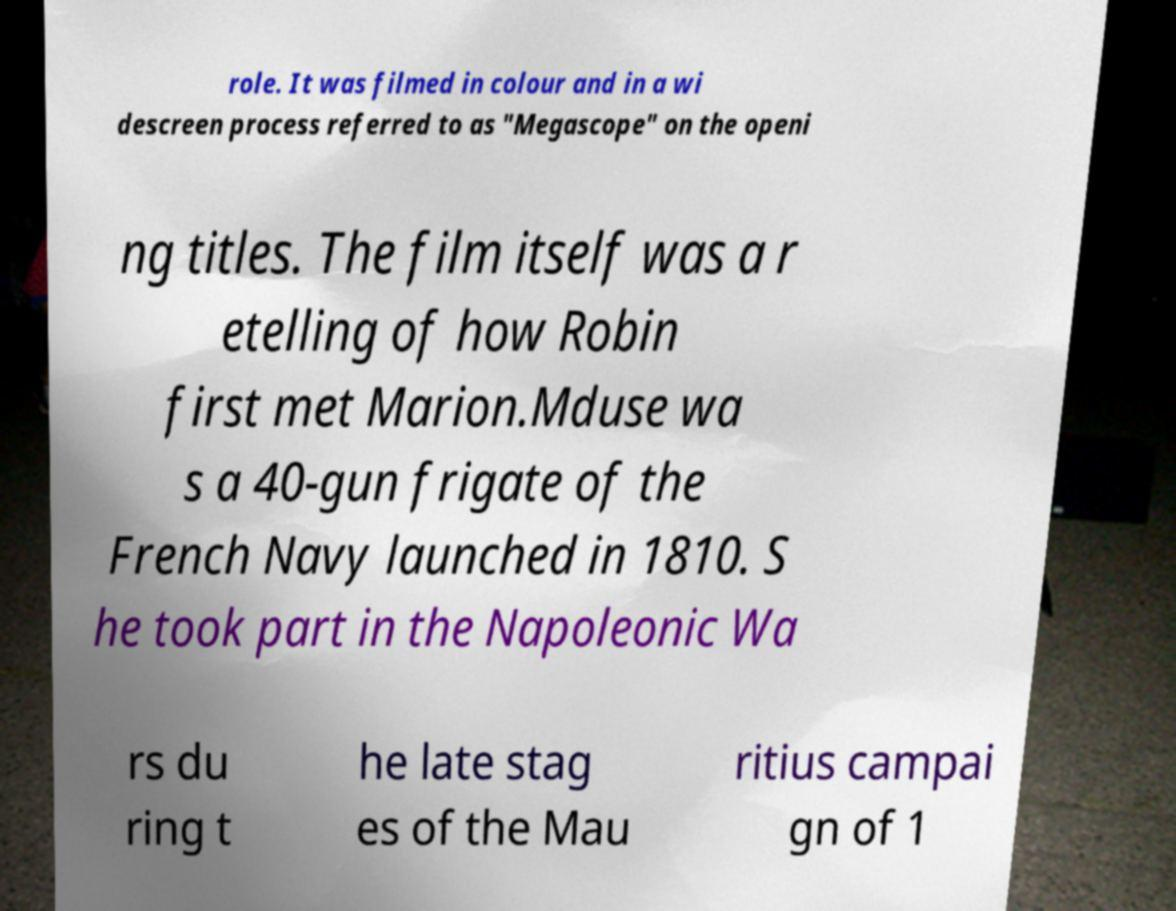Please read and relay the text visible in this image. What does it say? role. It was filmed in colour and in a wi descreen process referred to as "Megascope" on the openi ng titles. The film itself was a r etelling of how Robin first met Marion.Mduse wa s a 40-gun frigate of the French Navy launched in 1810. S he took part in the Napoleonic Wa rs du ring t he late stag es of the Mau ritius campai gn of 1 